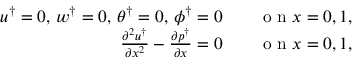Convert formula to latex. <formula><loc_0><loc_0><loc_500><loc_500>\begin{array} { r l } { u ^ { \dagger } = 0 , \, w ^ { \dagger } = 0 , \, \theta ^ { \dagger } = 0 , \, \phi ^ { \dagger } = 0 \quad } & o n x = 0 , 1 , } \\ { \frac { \partial ^ { 2 } u ^ { \dagger } } { \partial x ^ { 2 } } - \frac { \partial p ^ { \dagger } } { \partial x } = 0 \quad } & o n x = 0 , 1 , } \end{array}</formula> 